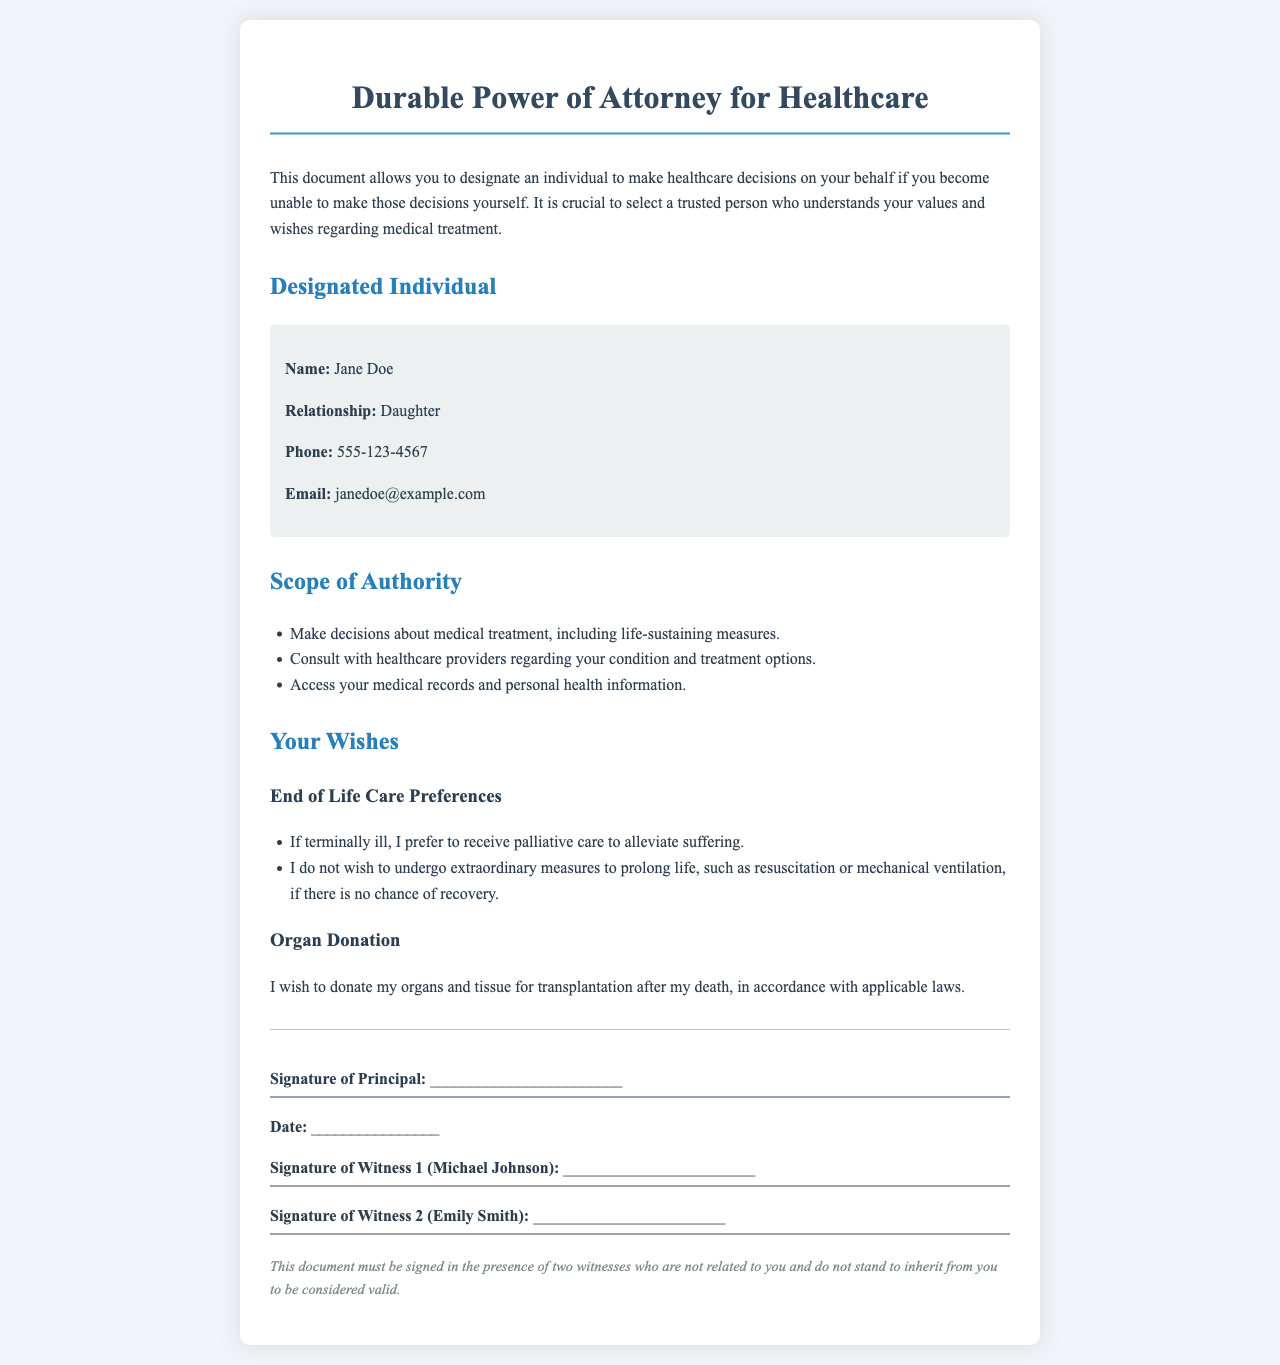What is the name of the designated individual? The name of the designated individual is specified in the document under the "Designated Individual" section.
Answer: Jane Doe What is the relationship of the designated individual to the principal? The relationship of the designated individual can be found in the same section as the name, indicating their connection to the principal.
Answer: Daughter What is the phone number of the designated individual? The phone number is provided in the "Designated Individual" section of the document.
Answer: 555-123-4567 What palliative care preference is stated for the principal? The preference for palliative care is outlined in the "End of Life Care Preferences" section regarding treatment if terminally ill.
Answer: Alleviate suffering What organ donation wish is expressed in the document? The document details the principal's wish regarding organ donation, found in the relevant section.
Answer: I wish to donate my organs and tissue for transplantation What signatures are required for the document to be valid? The document specifies the required signatures for validation, particularly in the "signature section".
Answer: Two witnesses What is the significance of the disclaimer in the document? The disclaimer reflects the requirements for the document's validity, including witness qualifications.
Answer: Validity conditions Does the principal wish to undergo extraordinary measures to prolong life? This is explained in the "End of Life Care Preferences" section of the document, specifically addressing treatment options.
Answer: No What must the witnesses not be related to the principal to ensure validity? The disclaimer states that there are specific conditions regarding the witnesses' relationship to the principal.
Answer: Related 